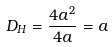Convert formula to latex. <formula><loc_0><loc_0><loc_500><loc_500>D _ { H } = \frac { 4 a ^ { 2 } } { 4 a } = a</formula> 